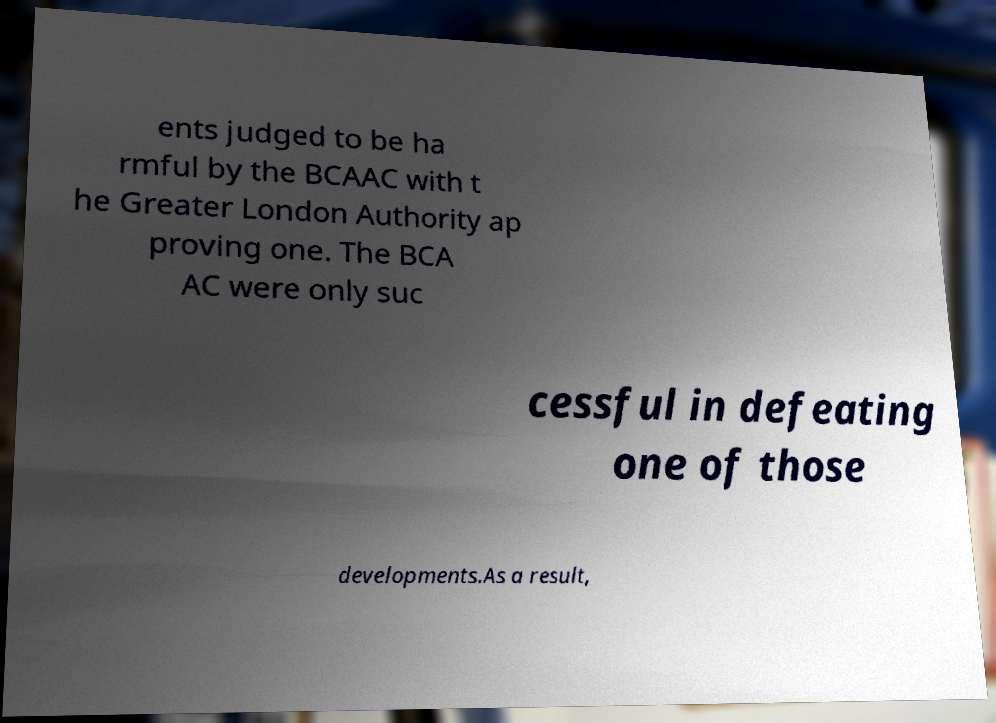I need the written content from this picture converted into text. Can you do that? ents judged to be ha rmful by the BCAAC with t he Greater London Authority ap proving one. The BCA AC were only suc cessful in defeating one of those developments.As a result, 